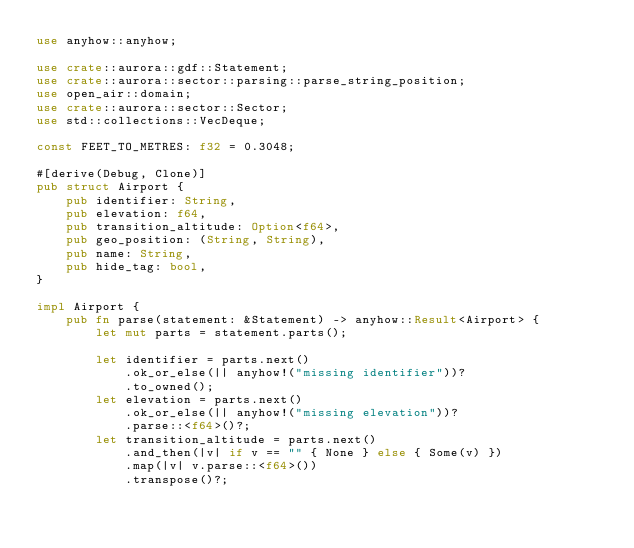<code> <loc_0><loc_0><loc_500><loc_500><_Rust_>use anyhow::anyhow;

use crate::aurora::gdf::Statement;
use crate::aurora::sector::parsing::parse_string_position;
use open_air::domain;
use crate::aurora::sector::Sector;
use std::collections::VecDeque;

const FEET_TO_METRES: f32 = 0.3048;

#[derive(Debug, Clone)]
pub struct Airport {
    pub identifier: String,
    pub elevation: f64,
    pub transition_altitude: Option<f64>,
    pub geo_position: (String, String),
    pub name: String,
    pub hide_tag: bool,
}

impl Airport {
    pub fn parse(statement: &Statement) -> anyhow::Result<Airport> {
        let mut parts = statement.parts();

        let identifier = parts.next()
            .ok_or_else(|| anyhow!("missing identifier"))?
            .to_owned();
        let elevation = parts.next()
            .ok_or_else(|| anyhow!("missing elevation"))?
            .parse::<f64>()?;
        let transition_altitude = parts.next()
            .and_then(|v| if v == "" { None } else { Some(v) })
            .map(|v| v.parse::<f64>())
            .transpose()?;</code> 